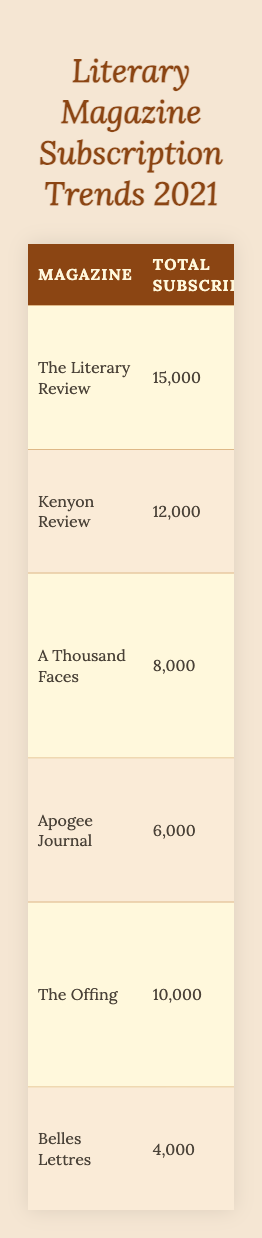What is the total number of subscriptions for "The Literary Review"? According to the table, "The Literary Review" has a total of 15,000 subscriptions as stated in the "Total Subscriptions" column.
Answer: 15,000 Which magazine has the highest percentage of diverse voices? In the table, "Apogee Journal" is listed with the highest percentage of diverse voices at 55%, found in the "PercentageDiverseVoices" column.
Answer: 55% How many magazines focus on diversity according to the table? All listed magazines in the table have a "FocusOnDiversity" value of "Yes," indicating that there are 6 magazines focusing on diversity.
Answer: 6 What is the average price of subscriptions for the magazines? The average price can be calculated by summing the average prices (20 + 25 + 15 + 10 + 17 + 12 = 109) and dividing by the number of magazines (109 / 6 ≈ 18.17).
Answer: 18.17 Which magazine has the most notable authors published? The magazine "The Literary Review" lists three notable authors published: Chigozie Obioma, Nnedi Okorafor, and Jasmine Warga, equating to three authors. Other magazines feature fewer authors.
Answer: The Literary Review What is the total number of subscriptions for magazines with a 40% or higher focus on diverse voices? The magazines that meet this criterion are "The Literary Review" (15,000), "Kenyon Review" (12,000), "A Thousand Faces" (8,000), "The Offing" (10,000), and "Apogee Journal" (6,000). Adding these gives (15,000 + 12,000 + 8,000 + 10,000 + 6,000 = 51,000).
Answer: 51,000 How many monthly issues does "Belles Lettres" publish? The table shows that "Belles Lettres" publishes 1 monthly issue as indicated in the "Monthly Issues" column.
Answer: 1 Which magazine offers subscriptions at the lowest average price? The table indicates that "Apogee Journal" has the lowest average price at $10, as observed in the "Average Price" column.
Answer: $10 Is there a correlation between the number of total subscriptions and the percentage of diverse voices? The table shows diverse voices percentages ranging from 30% to 55% with varying subscriptions. A detailed comparison does not show a direct correlation, as the one with the highest subscriptions doesn't have the highest percentage.
Answer: No correlation What is the average percentage of diverse voices for magazines that publish poetry? The magazines that publish poetry ("The Literary Review," "Kenyon Review," "Apogee Journal," "The Offing," and "Belles Lettres") have percentages of 45%, 38%, 55%, 40%, and 30%. Sum these percentages (45 + 38 + 55 + 40 + 30 = 208) and divide by 5 magazines (208 / 5 = 41.6).
Answer: 41.6 